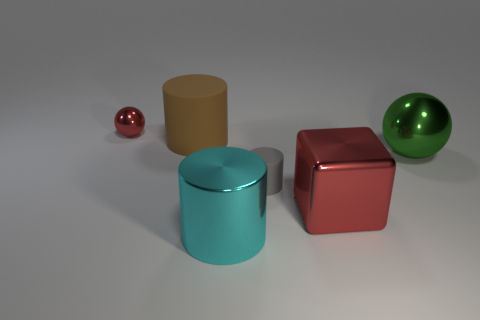Is the number of brown objects in front of the big green ball the same as the number of large green things right of the big cyan thing?
Give a very brief answer. No. What number of other things are made of the same material as the cyan cylinder?
Give a very brief answer. 3. What number of tiny objects are gray rubber cylinders or blocks?
Ensure brevity in your answer.  1. Are there an equal number of small red objects in front of the gray object and gray rubber cylinders?
Offer a terse response. No. Is there a tiny object in front of the big thing left of the cyan thing?
Provide a succinct answer. Yes. What number of other things are there of the same color as the tiny metallic thing?
Provide a short and direct response. 1. What color is the tiny ball?
Your response must be concise. Red. What size is the metallic thing that is behind the large red shiny object and right of the small red metal ball?
Make the answer very short. Large. How many objects are large cyan shiny cylinders in front of the red shiny ball or tiny brown rubber balls?
Your answer should be very brief. 1. There is a small object that is made of the same material as the large brown cylinder; what is its shape?
Provide a succinct answer. Cylinder. 